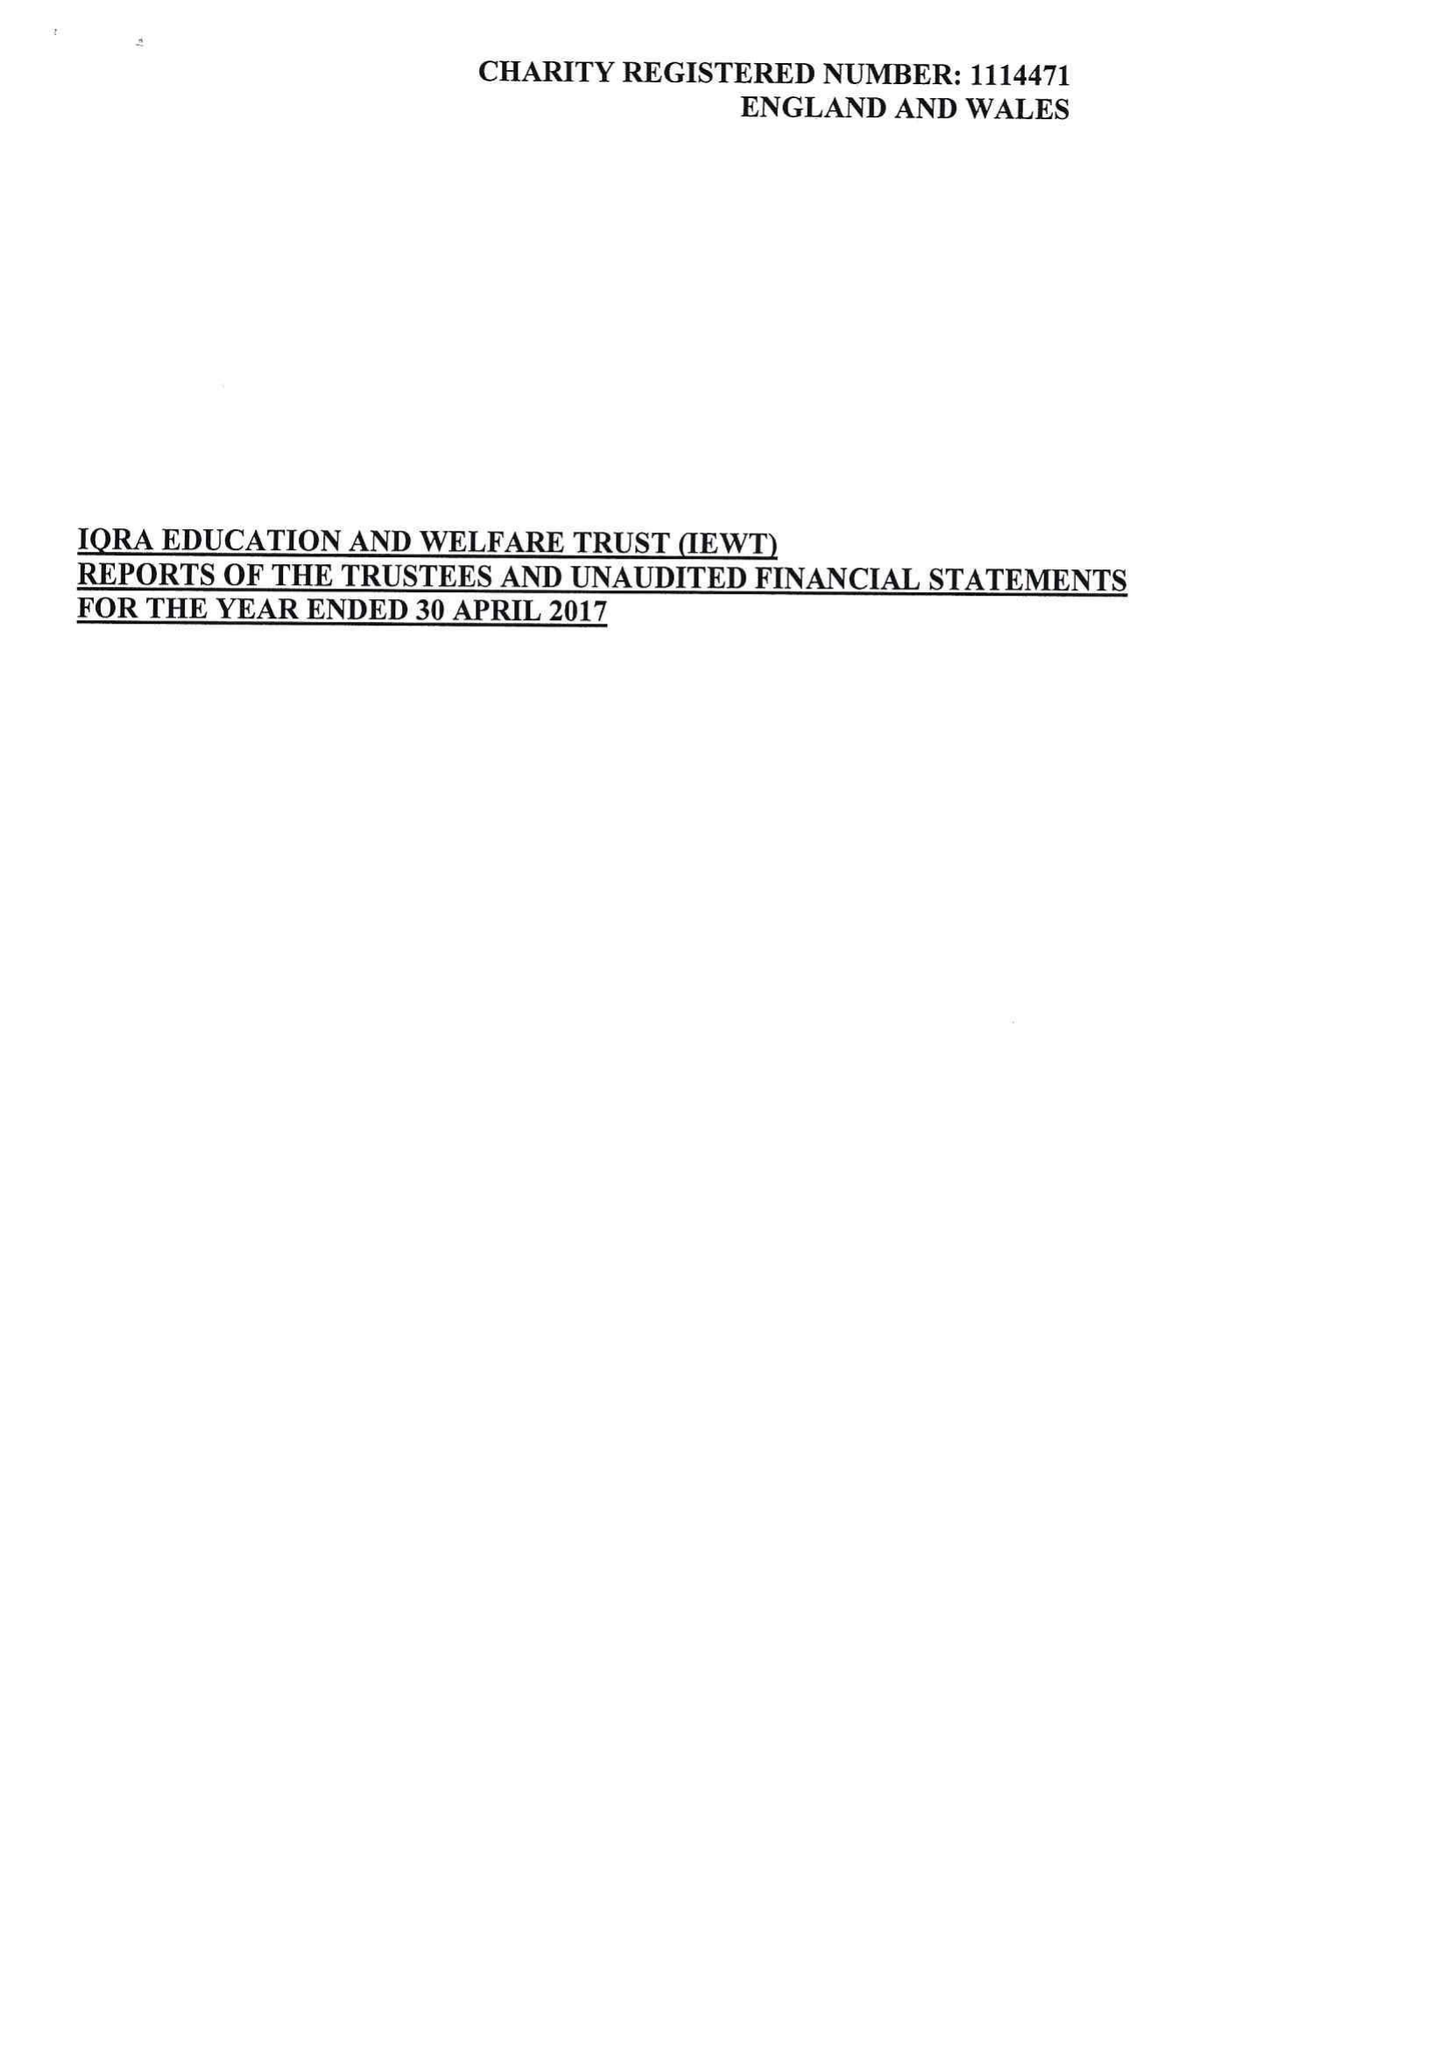What is the value for the report_date?
Answer the question using a single word or phrase. 2017-04-30 